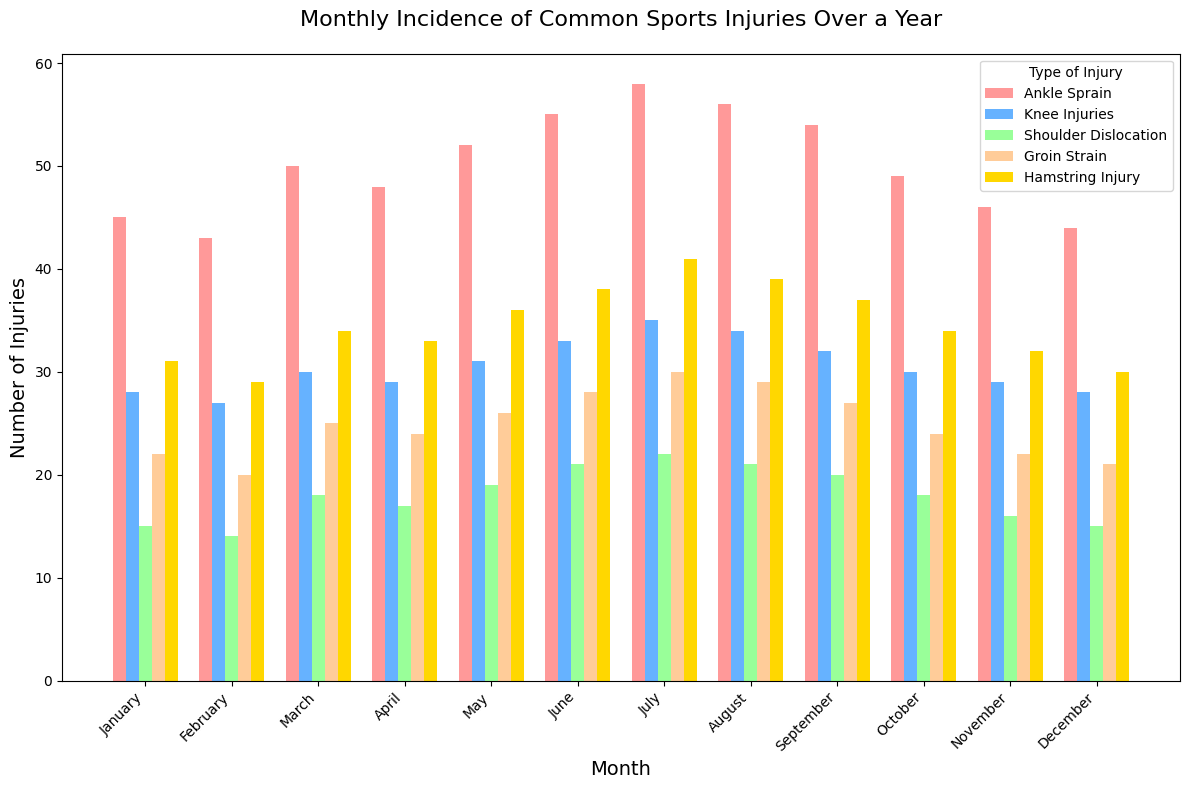Which month had the highest number of ankle sprains? Observe the heights of the bars for ankle sprains. The tallest bar corresponds to July.
Answer: July What is the difference in the number of shoulder dislocations between May and September? Locate May and September on the x-axis, and observe the height of the shoulder dislocation bars. May has 19 and September has 20. The difference is 20 - 19.
Answer: 1 Which injury type is most common in June? Observe the heights of the bars for June. The tallest bar corresponds to ankle sprains.
Answer: Ankle Sprain How many total injuries were recorded in January? Sum the heights of all bars in January: 45 (ankle sprain) + 28 (knee injuries) + 15 (shoulder dislocation) + 22 (groin strain) + 31 (hamstring injury)
Answer: 141 What is the average number of knee injuries reported in the first quarter (January to March)? Sum knee injuries in January (28), February (27), and March (30), divide by 3: (28 + 27 + 30) / 3
Answer: 28.33 Compare the number of hamstring injuries in May and July. Which month had more? Locate May and July on the x-axis and observe the hamstring injury bars. May has 36 injuries, July has 41 injuries.
Answer: July What is the total number of groin strains recorded in the last quarter (October to December)? Sum groin strains in October (24), November (22), and December (21): 24 + 22 + 21
Answer: 67 Which injury type has the most consistent number of cases throughout the year? By visually comparing the height variations across months for each injury type, the knee injuries bars show the least variation.
Answer: Knee Injuries Which month had fewer total injuries, February or November? Sum all injuries in February: 43 (ankle) + 27 (knee) + 14 (shoulder) + 20 (groin) + 29 (hamstring) = 133
Sum all injuries in November: 46 (ankle) + 29 (knee) + 16 (shoulder) + 22 (groin) + 32 (hamstring) = 145
Answer: February 